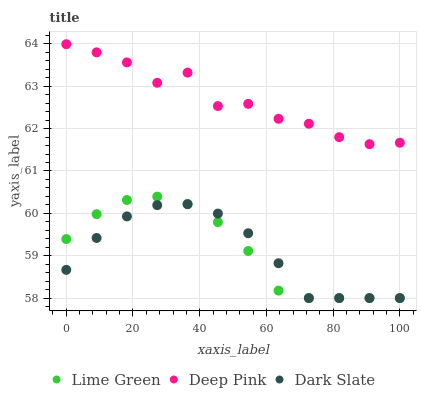Does Dark Slate have the minimum area under the curve?
Answer yes or no. Yes. Does Deep Pink have the maximum area under the curve?
Answer yes or no. Yes. Does Lime Green have the minimum area under the curve?
Answer yes or no. No. Does Lime Green have the maximum area under the curve?
Answer yes or no. No. Is Dark Slate the smoothest?
Answer yes or no. Yes. Is Deep Pink the roughest?
Answer yes or no. Yes. Is Lime Green the smoothest?
Answer yes or no. No. Is Lime Green the roughest?
Answer yes or no. No. Does Dark Slate have the lowest value?
Answer yes or no. Yes. Does Deep Pink have the lowest value?
Answer yes or no. No. Does Deep Pink have the highest value?
Answer yes or no. Yes. Does Lime Green have the highest value?
Answer yes or no. No. Is Dark Slate less than Deep Pink?
Answer yes or no. Yes. Is Deep Pink greater than Dark Slate?
Answer yes or no. Yes. Does Dark Slate intersect Lime Green?
Answer yes or no. Yes. Is Dark Slate less than Lime Green?
Answer yes or no. No. Is Dark Slate greater than Lime Green?
Answer yes or no. No. Does Dark Slate intersect Deep Pink?
Answer yes or no. No. 